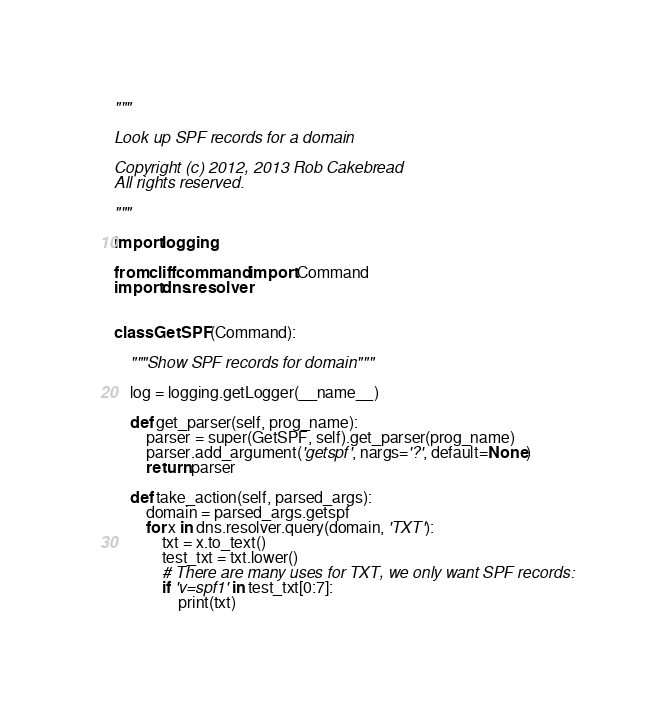Convert code to text. <code><loc_0><loc_0><loc_500><loc_500><_Python_>
"""

Look up SPF records for a domain

Copyright (c) 2012, 2013 Rob Cakebread
All rights reserved.

"""

import logging

from cliff.command import Command
import dns.resolver


class GetSPF(Command):

    """Show SPF records for domain"""

    log = logging.getLogger(__name__)

    def get_parser(self, prog_name):
        parser = super(GetSPF, self).get_parser(prog_name)
        parser.add_argument('getspf', nargs='?', default=None)
        return parser

    def take_action(self, parsed_args):
        domain = parsed_args.getspf
        for x in dns.resolver.query(domain, 'TXT'):
            txt = x.to_text()
            test_txt = txt.lower()
            # There are many uses for TXT, we only want SPF records:
            if 'v=spf1' in test_txt[0:7]:
                print(txt)
</code> 